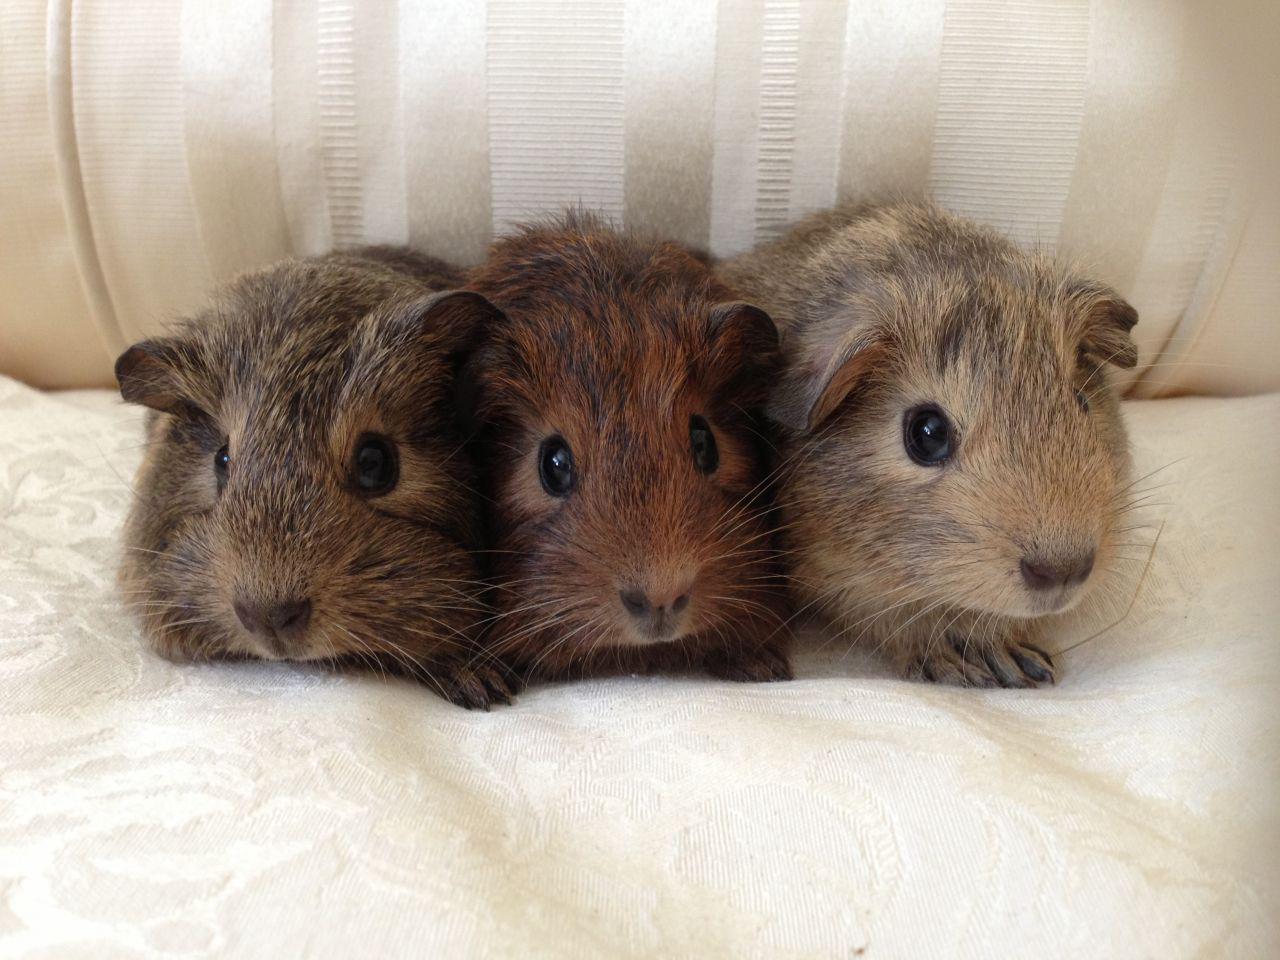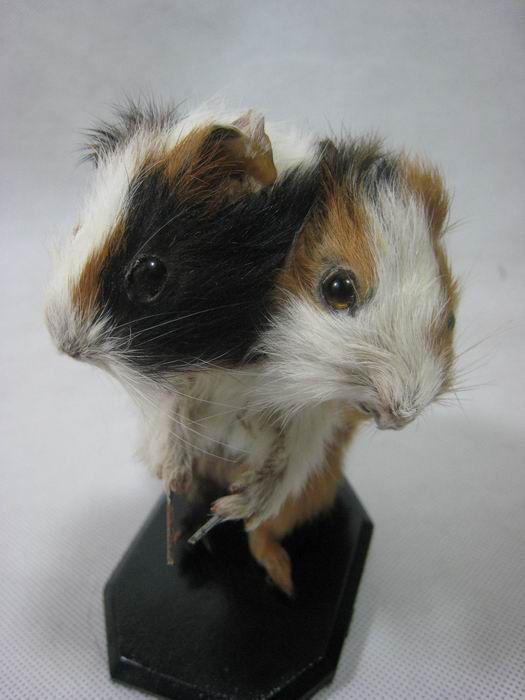The first image is the image on the left, the second image is the image on the right. Assess this claim about the two images: "There are no more than five animals". Correct or not? Answer yes or no. Yes. The first image is the image on the left, the second image is the image on the right. Given the left and right images, does the statement "There are exactly three rodents in the image on the left." hold true? Answer yes or no. Yes. 